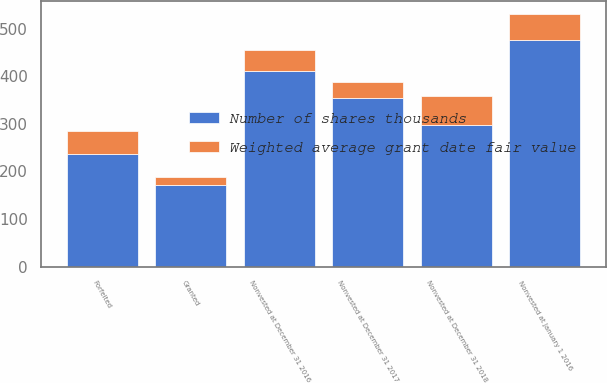Convert chart to OTSL. <chart><loc_0><loc_0><loc_500><loc_500><stacked_bar_chart><ecel><fcel>Nonvested at January 1 2016<fcel>Granted<fcel>Forfeited<fcel>Nonvested at December 31 2016<fcel>Nonvested at December 31 2017<fcel>Nonvested at December 31 2018<nl><fcel>Number of shares thousands<fcel>475<fcel>171<fcel>236<fcel>410<fcel>355<fcel>297<nl><fcel>Weighted average grant date fair value<fcel>56.55<fcel>16.61<fcel>49.37<fcel>43.99<fcel>32.35<fcel>60.35<nl></chart> 